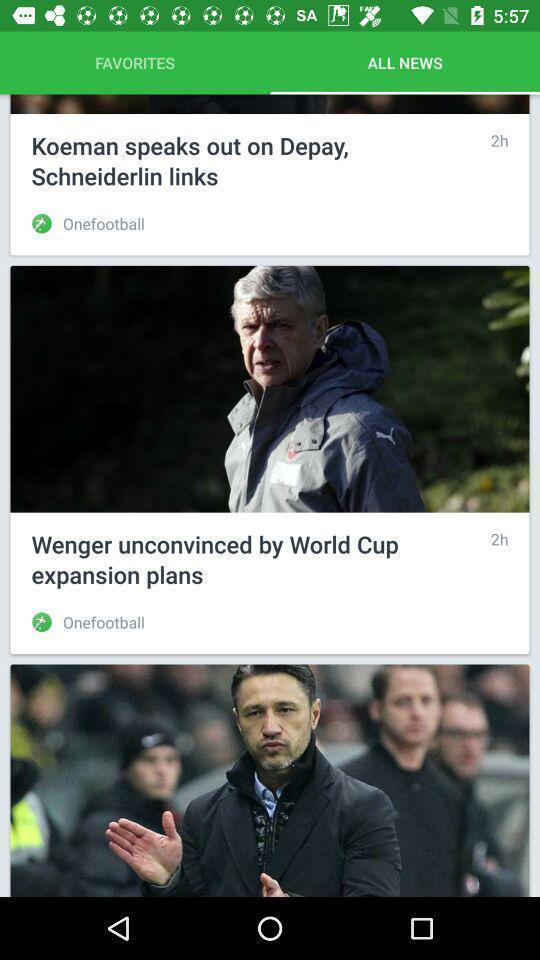What is the overall content of this screenshot? Page displaying with list of news feed. 